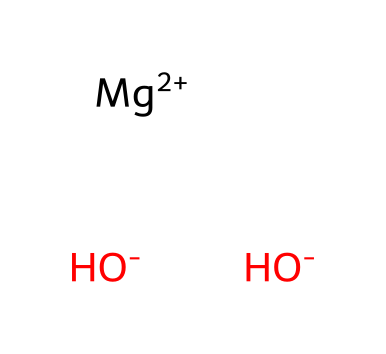What is the common name of this chemical? The SMILES representation indicates that it consists of magnesium and hydroxide ions. This arrangement corresponds to the compound commonly known as magnesium hydroxide, which is widely used as an antacid.
Answer: magnesium hydroxide How many hydroxide ions are present in the structure? The SMILES notation shows two hydroxide (OH-) ions attached to the magnesium ion (Mg+2). Thus, there are two hydroxide ions in the structure.
Answer: 2 What is the charge of the magnesium ion in this compound? Observing the SMILES representation, it shows the magnesium ion as Mg+2, indicating it has a +2 charge.
Answer: +2 What is the total number of atoms in this chemical? The structure indicates one magnesium atom (Mg), two oxygen atoms (one from each OH-), and two hydrogen atoms (again from each OH-), totaling five atoms.
Answer: 5 What type of compound is magnesium hydroxide classified as? Given the presence of hydroxide ions in the structure (OH-), along with the metal magnesium, this compound is classified as a base.
Answer: base What role do hydroxide ions play in this antacid medication? Hydroxide ions (OH-) neutralize stomach acid (HCl) by reacting with it, reducing acidity in the stomach, which is the main action of an antacid.
Answer: neutralize acidity 